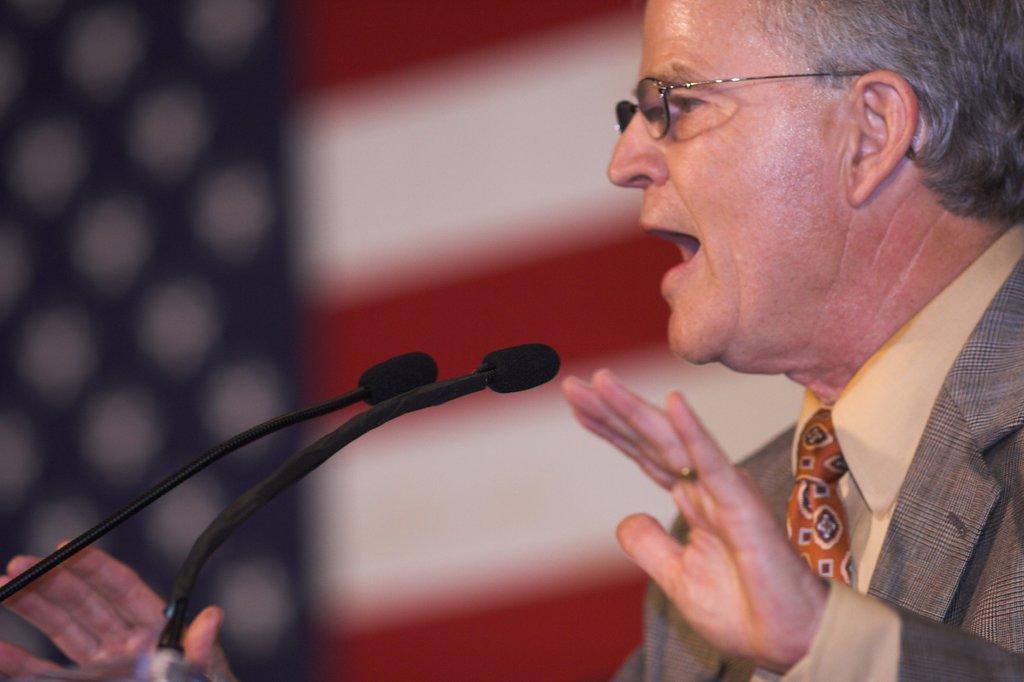In one or two sentences, can you explain what this image depicts? In this image I can see the person with the blazer, shirt, tie and the specs and there are two mics in-front of the person. I can see the blurred background. 